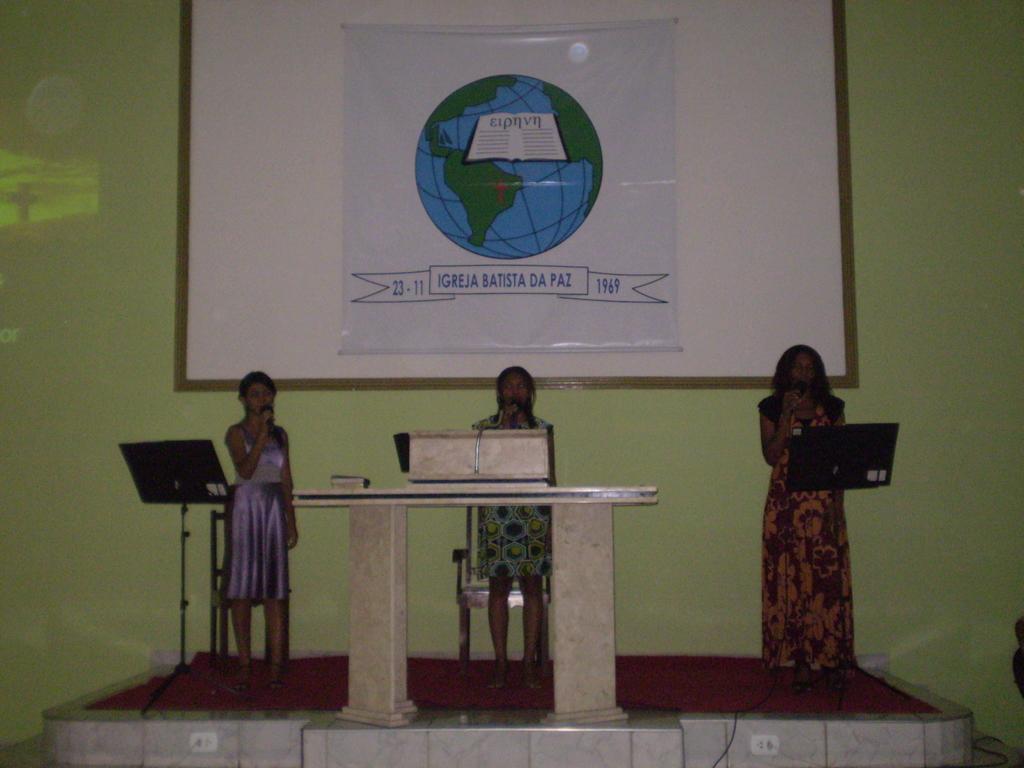Please provide a concise description of this image. In this image we can see three persons standing on a surface and holding objects. In front of the persons we can see stands and a table. Behind the persons there is a wall and a whiteboard is attached to the wall. On the board we can see a banner on which there is an image and some text. 